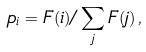<formula> <loc_0><loc_0><loc_500><loc_500>p _ { i } = F ( i ) / \sum _ { j } F ( j ) \, ,</formula> 